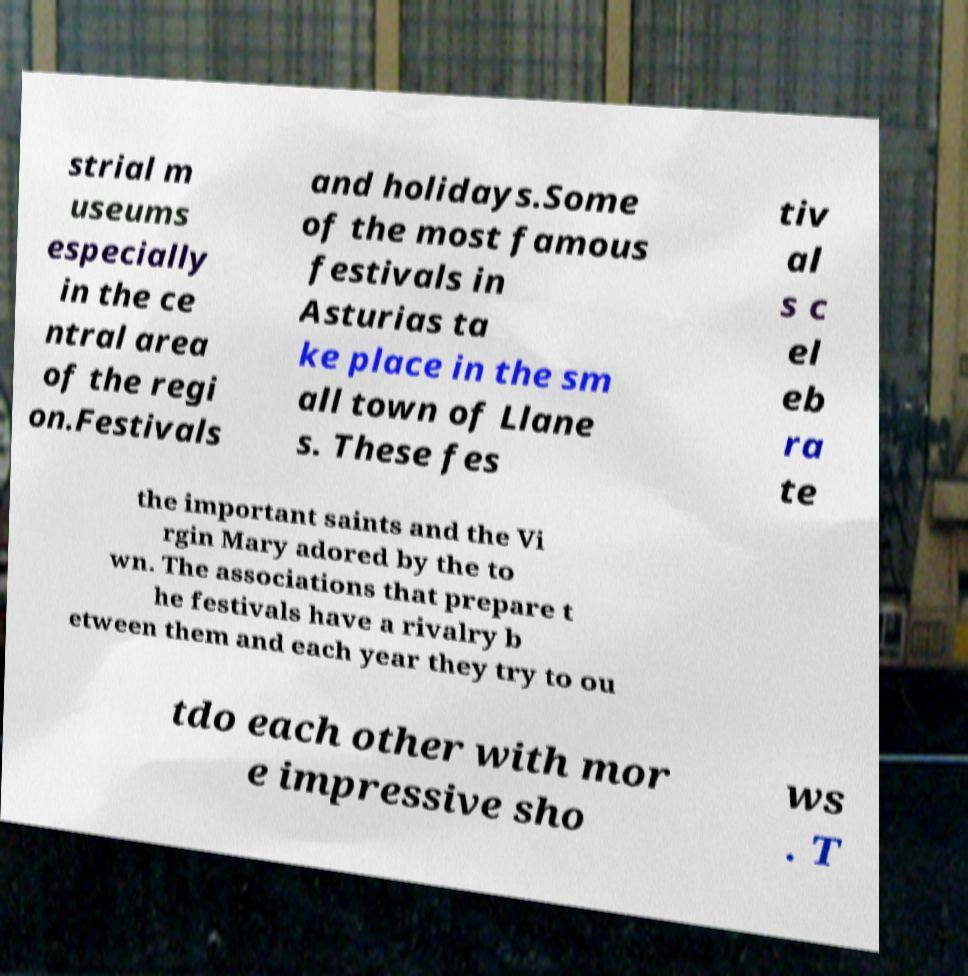There's text embedded in this image that I need extracted. Can you transcribe it verbatim? strial m useums especially in the ce ntral area of the regi on.Festivals and holidays.Some of the most famous festivals in Asturias ta ke place in the sm all town of Llane s. These fes tiv al s c el eb ra te the important saints and the Vi rgin Mary adored by the to wn. The associations that prepare t he festivals have a rivalry b etween them and each year they try to ou tdo each other with mor e impressive sho ws . T 